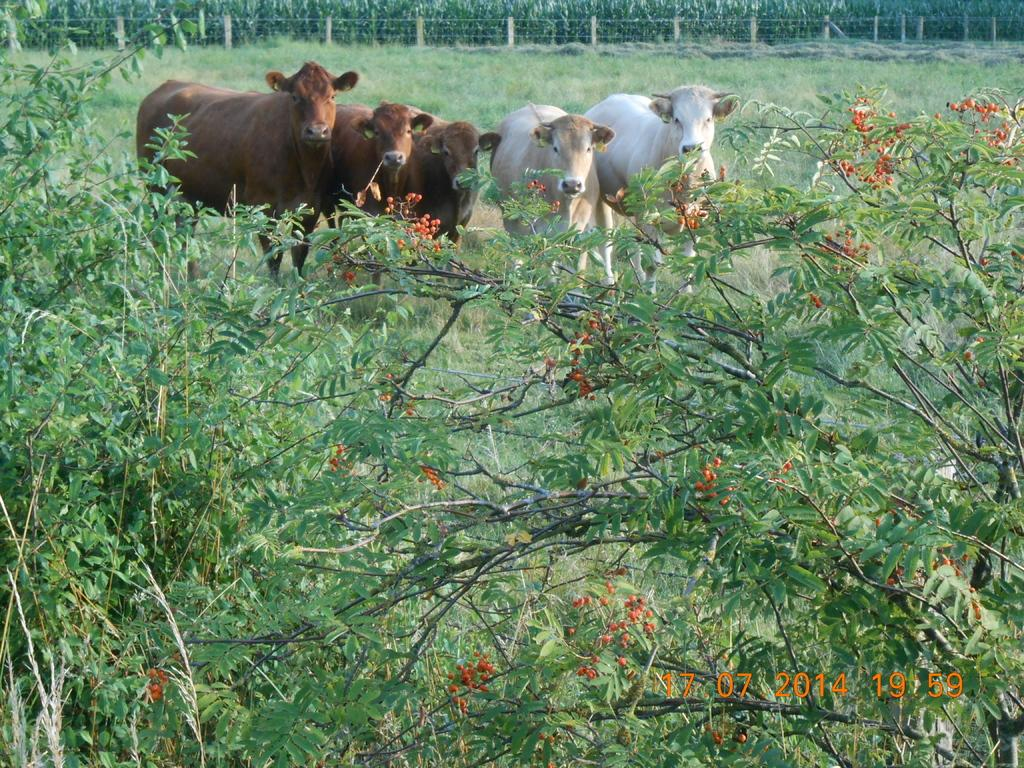What is the main subject of the image? The main subject of the image is animals standing on the ground. What type of natural environment is visible in the image? Trees and grass are visible in the image, indicating a natural setting. What type of barrier is present in the image? There is a fence in the image, which may serve as a boundary or enclosure. Where is the watermark located in the image? The watermark is located on the bottom right side of the image. What type of chicken can be heard in the background? There is no chicken present in the image, nor is there any sound mentioned or depicted. 